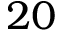<formula> <loc_0><loc_0><loc_500><loc_500>2 0</formula> 